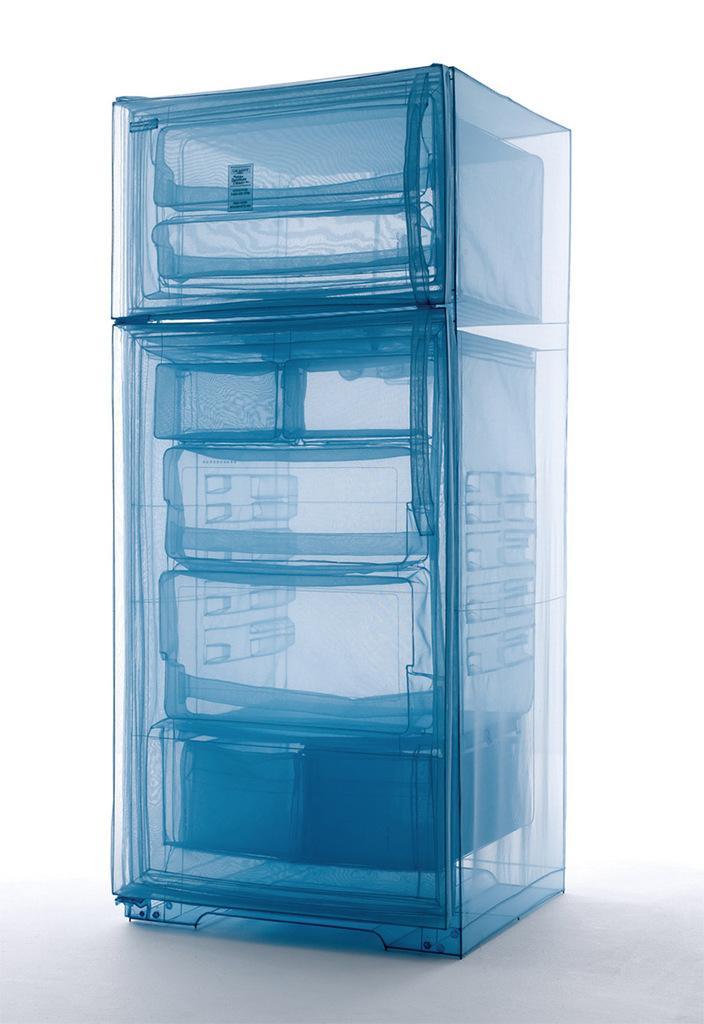In one or two sentences, can you explain what this image depicts? Background portion of the picture is white in color. In this picture we can see a refrigerator. 